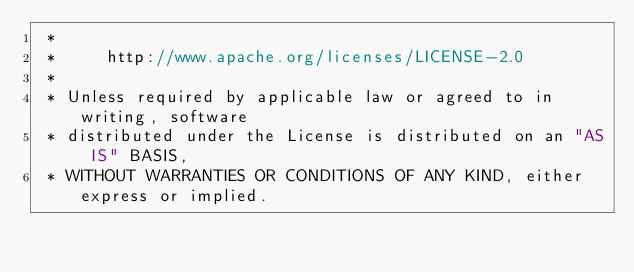<code> <loc_0><loc_0><loc_500><loc_500><_Cuda_> *
 *     http://www.apache.org/licenses/LICENSE-2.0
 *
 * Unless required by applicable law or agreed to in writing, software
 * distributed under the License is distributed on an "AS IS" BASIS,
 * WITHOUT WARRANTIES OR CONDITIONS OF ANY KIND, either express or implied.</code> 